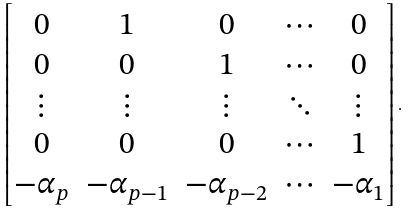Convert formula to latex. <formula><loc_0><loc_0><loc_500><loc_500>\begin{bmatrix} 0 & 1 & 0 & \cdots & 0 \\ 0 & 0 & 1 & \cdots & 0 \\ \vdots & \vdots & \vdots & \ddots & \vdots \\ 0 & 0 & 0 & \cdots & 1 \\ - \alpha _ { p } & - \alpha _ { p - 1 } & - \alpha _ { p - 2 } & \cdots & - \alpha _ { 1 } \end{bmatrix} .</formula> 